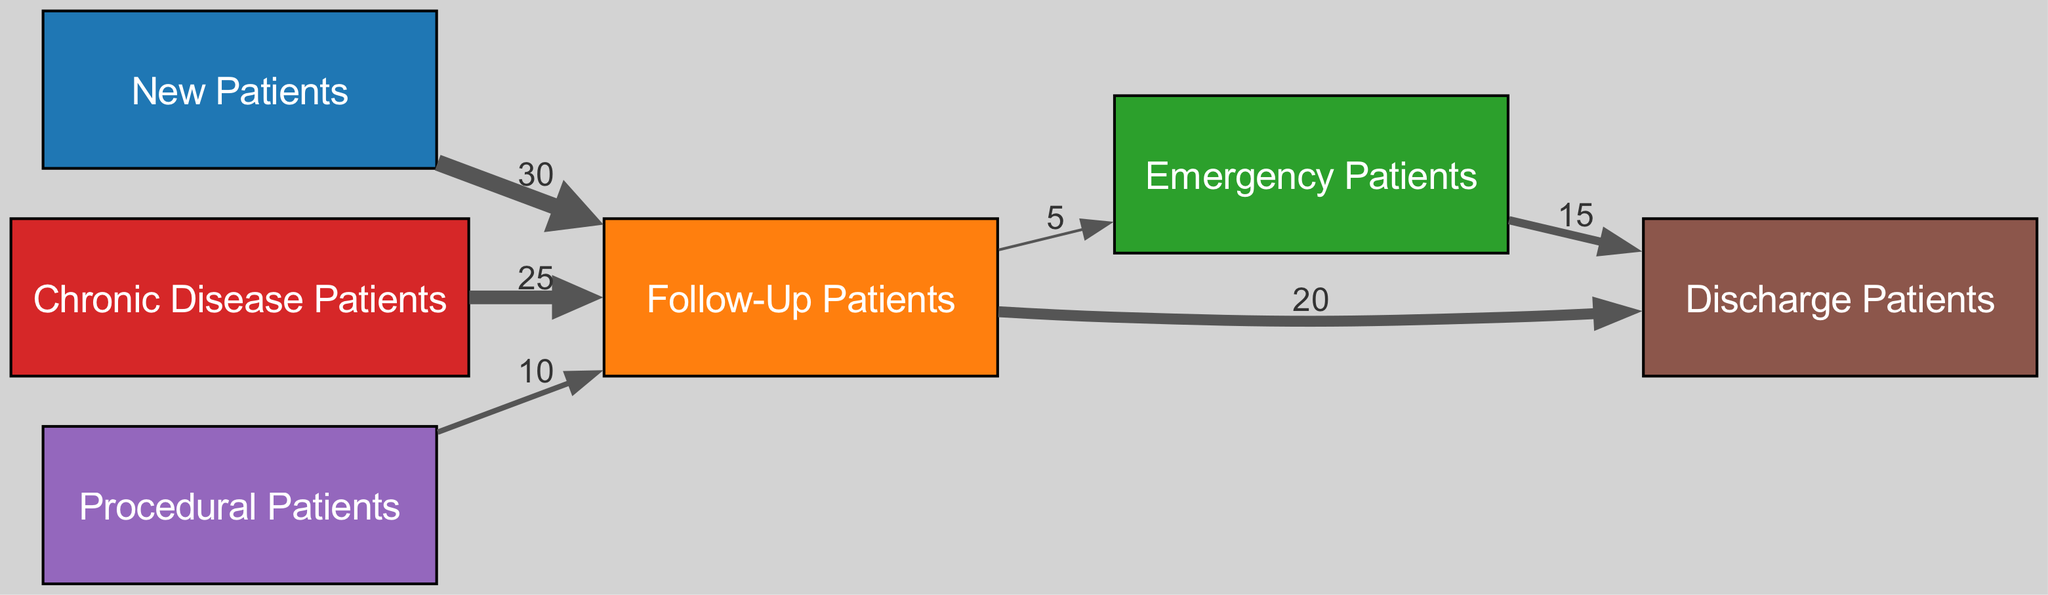What is the total number of nodes in the diagram? The diagram lists 6 unique patient types: New Patients, Follow-Up Patients, Emergency Patients, Chronic Disease Patients, Procedural Patients, and Discharge Patients. Counting these gives a total of 6 nodes.
Answer: 6 How many patients transition from Follow-Up Patients to Discharge Patients? The diagram shows a link from Follow-Up Patients to Discharge Patients with a value of 20. This indicates that 20 Follow-Up Patients transition to Discharge Patients.
Answer: 20 What is the value indicating the flow from New Patients to Follow-Up Patients? There is a direct link from New Patients to Follow-Up Patients with a value of 30, meaning 30 New Patients become Follow-Up Patients.
Answer: 30 Which patient type has the highest flow into Follow-Up Patients? The inflow into Follow-Up Patients comes from New Patients (30), Chronic Disease Patients (25), and Procedural Patients (10). The highest flow into Follow-Up Patients is from New Patients with a value of 30.
Answer: New Patients How many patients flow from Emergency Patients to Discharge Patients? The transition from Emergency Patients to Discharge Patients is represented by a link with a value of 15, indicating that 15 Emergency Patients are discharged after care.
Answer: 15 If 25 Chronic Disease Patients flow into Follow-Up Patients, how does this impact the total flow into Follow-Up Patients? The flow into Follow-Up Patients consists of 30 from New Patients, 25 from Chronic Disease Patients, and 10 from Procedural Patients, resulting in a total inflow of 30 + 25 + 10 = 65 patients to Follow-Up Patients.
Answer: 65 What percentage of Emergency Patients are discharged? The diagram shows 15 Emergency Patients transitioning to Discharge Patients from a total of 20 Emergency Patients (5 flow to Follow-Up Patients). Therefore, the percentage of Emergency Patients discharged is (15/20) * 100 = 75%.
Answer: 75% Which patient type has the lowest flow into Follow-Up Patients? The inflow into Follow-Up Patients includes New Patients (30), Chronic Disease Patients (25), and Procedural Patients (10). The lowest flow from these patient types is from Procedural Patients with a value of 10.
Answer: Procedural Patients 